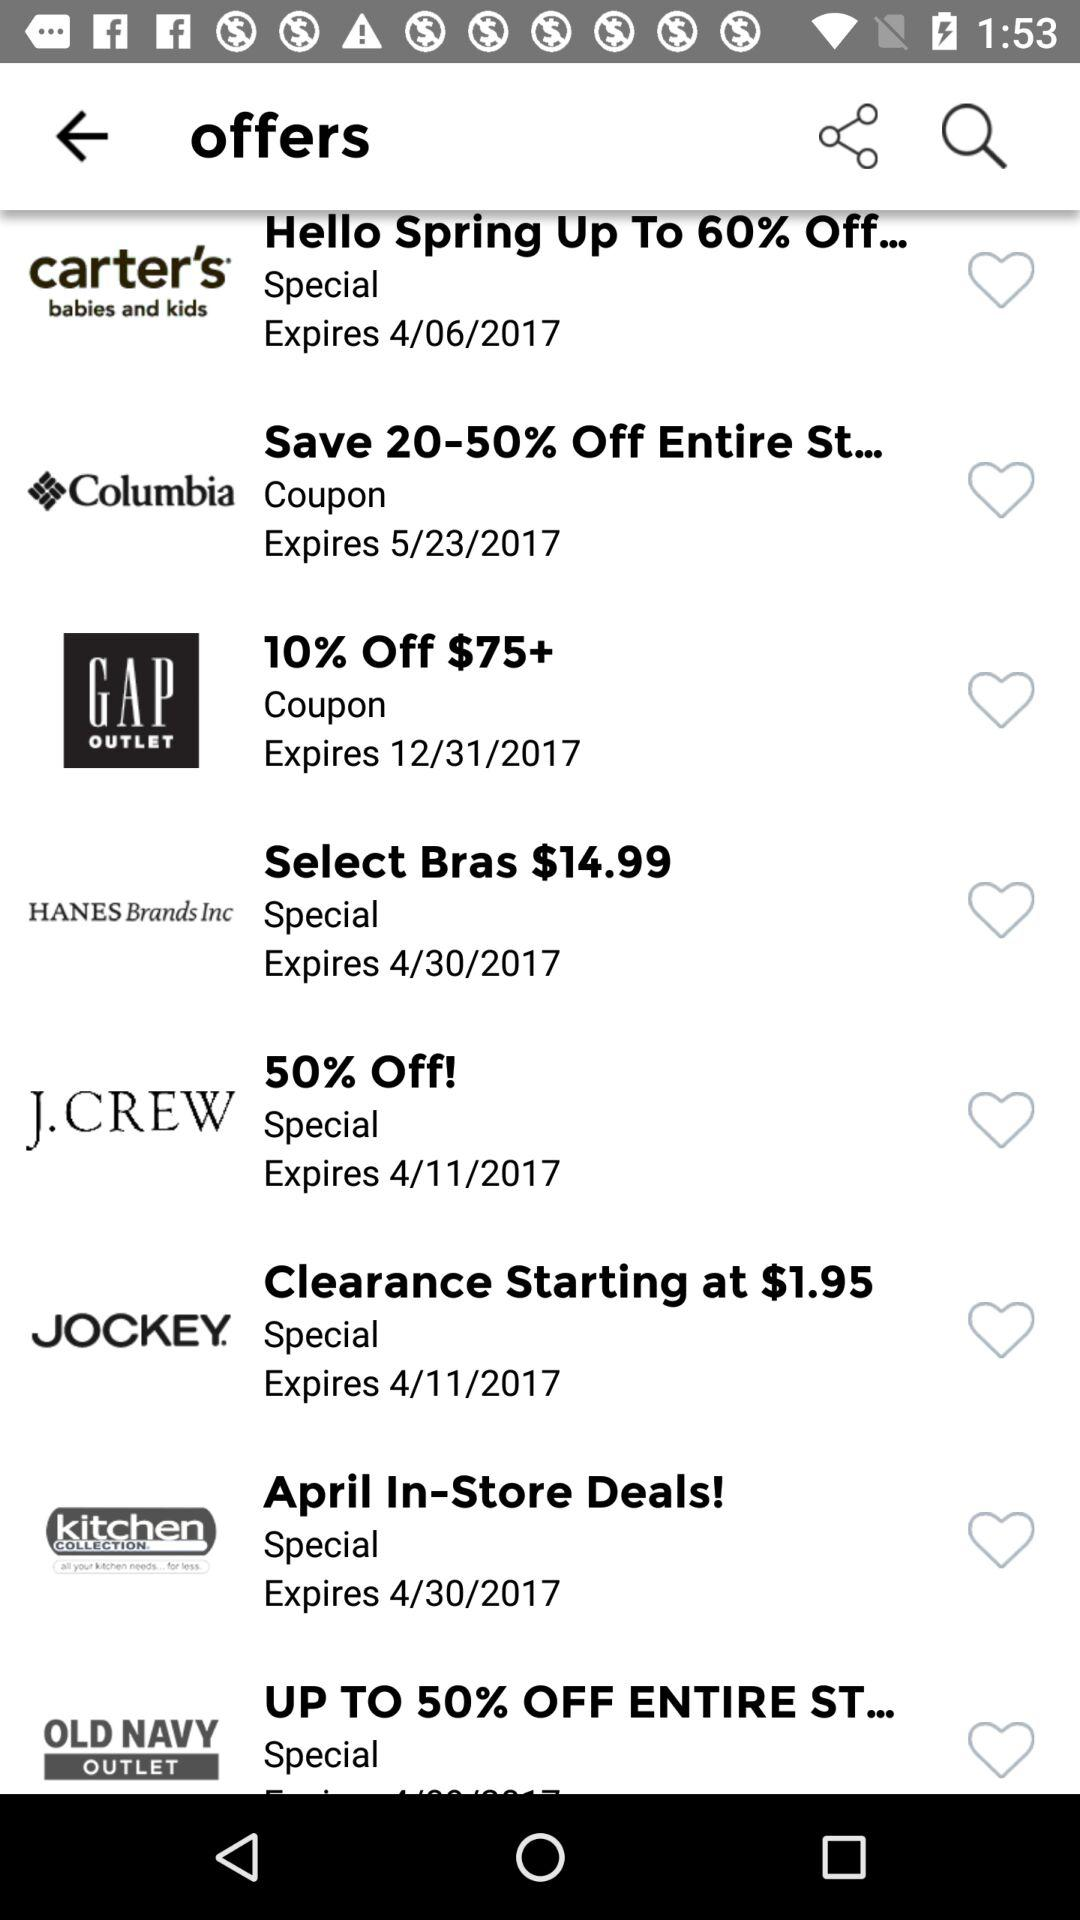What is the discount given on the J.Crew coupon? The discount is "50%". 